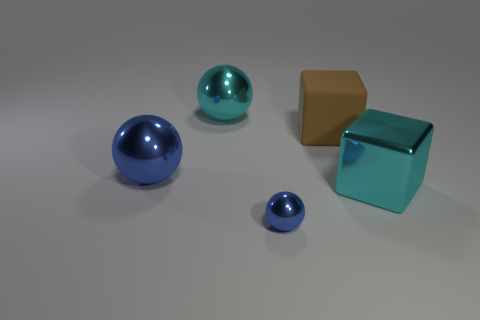What is the shape of the big metal object that is the same color as the big metal block?
Your answer should be compact. Sphere. How many other big cyan things are the same shape as the rubber thing?
Offer a terse response. 1. Is the shape of the big blue thing the same as the small shiny thing?
Give a very brief answer. Yes. The cyan cube has what size?
Provide a short and direct response. Large. How many green shiny spheres are the same size as the cyan metallic sphere?
Your answer should be compact. 0. Is the size of the cyan thing that is to the right of the brown block the same as the shiny sphere that is behind the large brown rubber cube?
Offer a terse response. Yes. There is a big blue thing in front of the cyan ball; what is its shape?
Offer a terse response. Sphere. There is a blue thing that is behind the big shiny thing that is to the right of the small shiny sphere; what is its material?
Your response must be concise. Metal. Is there another rubber thing that has the same color as the large matte object?
Your answer should be compact. No. Does the cyan cube have the same size as the shiny thing that is behind the brown matte block?
Your answer should be compact. Yes. 